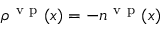<formula> <loc_0><loc_0><loc_500><loc_500>\rho ^ { { v p } } ( x ) = - n ^ { { v p } } ( x )</formula> 